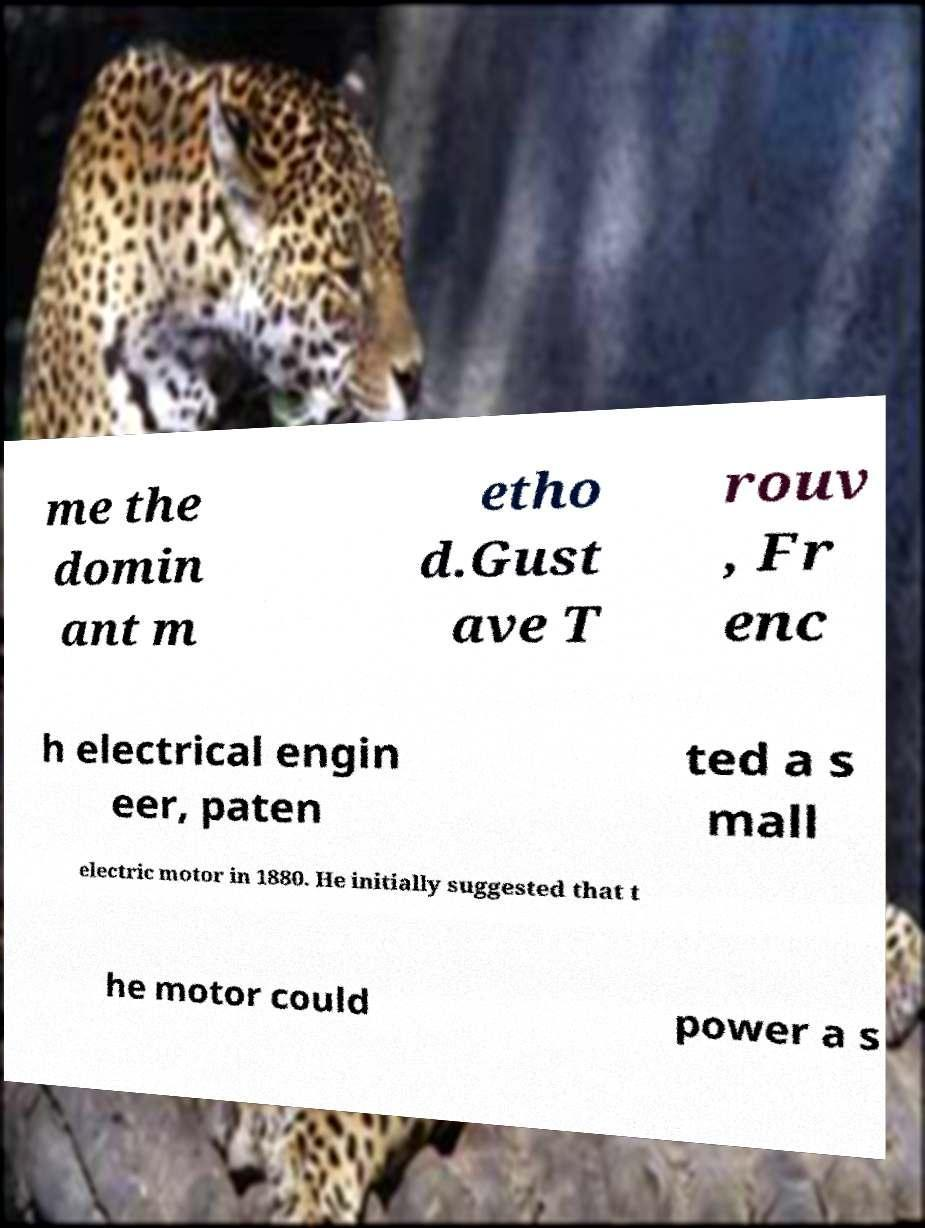For documentation purposes, I need the text within this image transcribed. Could you provide that? me the domin ant m etho d.Gust ave T rouv , Fr enc h electrical engin eer, paten ted a s mall electric motor in 1880. He initially suggested that t he motor could power a s 